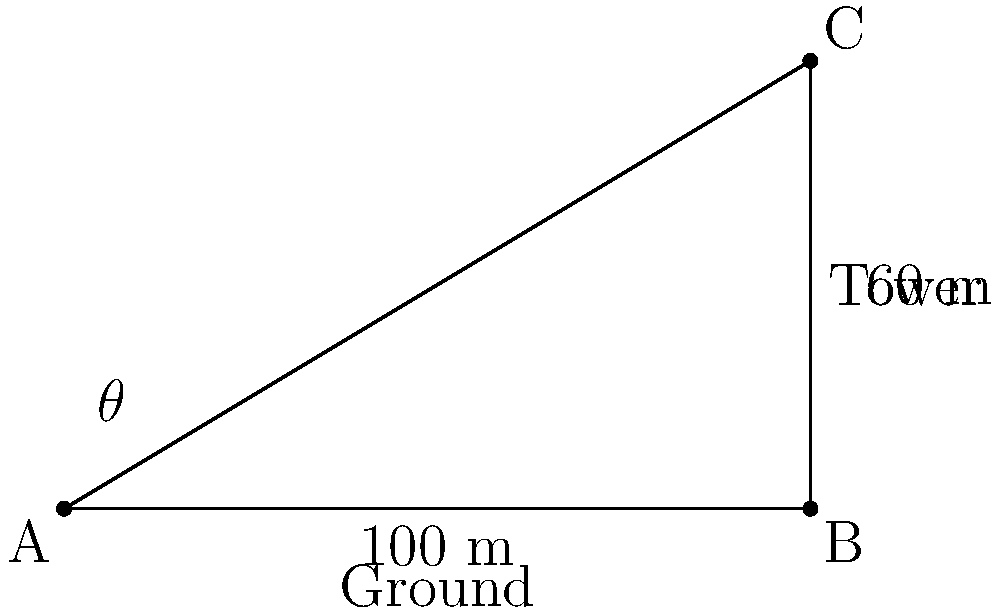As a park ranger, you're setting up an observation tower to monitor wildlife in a protected area. The tower is 60 meters tall and located 100 meters away from your current position on the ground. What is the angle of elevation (in degrees) you need to look up to observe the top of the tower? To solve this problem, we'll use trigonometry, specifically the tangent function. Let's approach this step-by-step:

1) First, let's identify the parts of the right triangle formed by the observer, the base of the tower, and the top of the tower:
   - The adjacent side is the horizontal distance to the tower: 100 meters
   - The opposite side is the height of the tower: 60 meters
   - The angle we're looking for is the angle of elevation, let's call it $\theta$

2) The tangent of an angle in a right triangle is the ratio of the opposite side to the adjacent side:

   $\tan(\theta) = \frac{\text{opposite}}{\text{adjacent}} = \frac{60}{100} = 0.6$

3) To find the angle $\theta$, we need to use the inverse tangent (arctan or $\tan^{-1}$) function:

   $\theta = \tan^{-1}(0.6)$

4) Using a calculator or trigonometric tables:

   $\theta \approx 30.96^\circ$

5) Rounding to the nearest tenth of a degree:

   $\theta \approx 31.0^\circ$

Therefore, the angle of elevation to observe the top of the tower is approximately 31.0°.
Answer: $31.0^\circ$ 